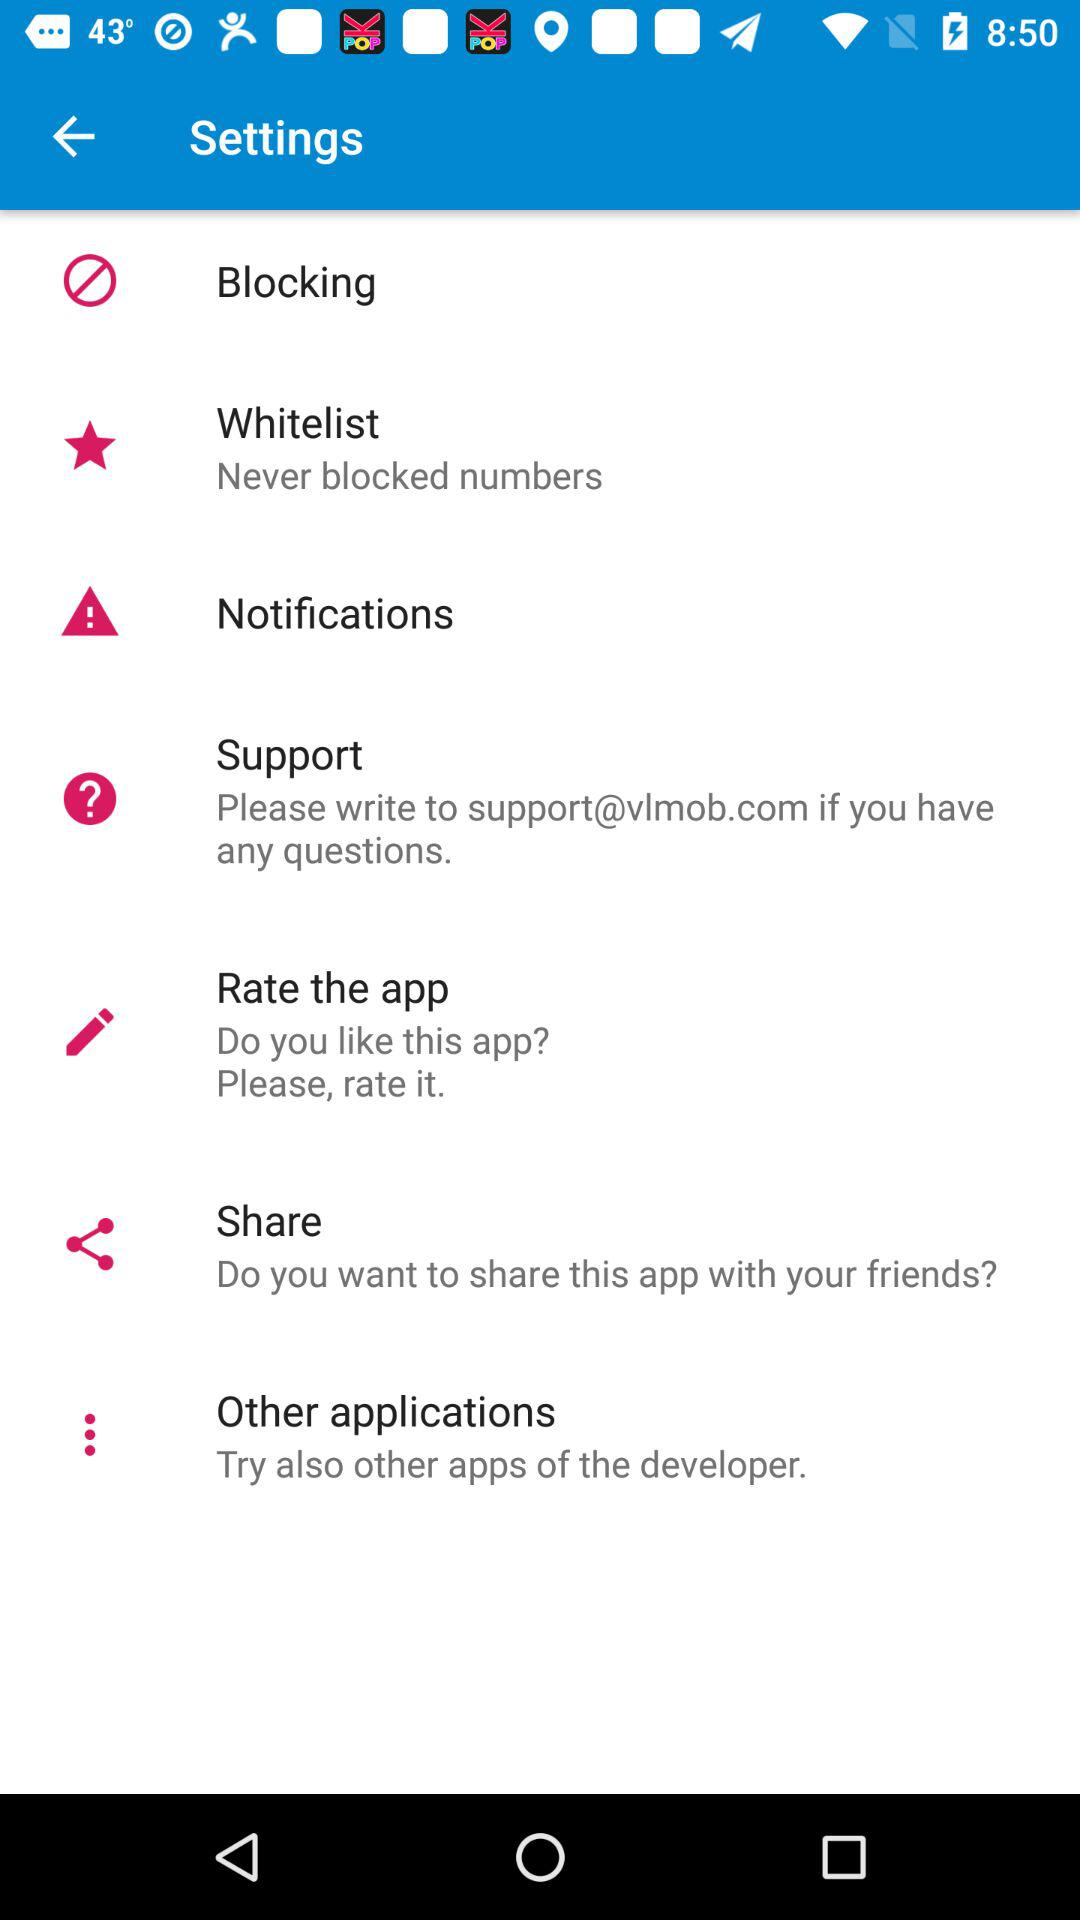What is the support email address? The support email address is support@vlmob.com. 